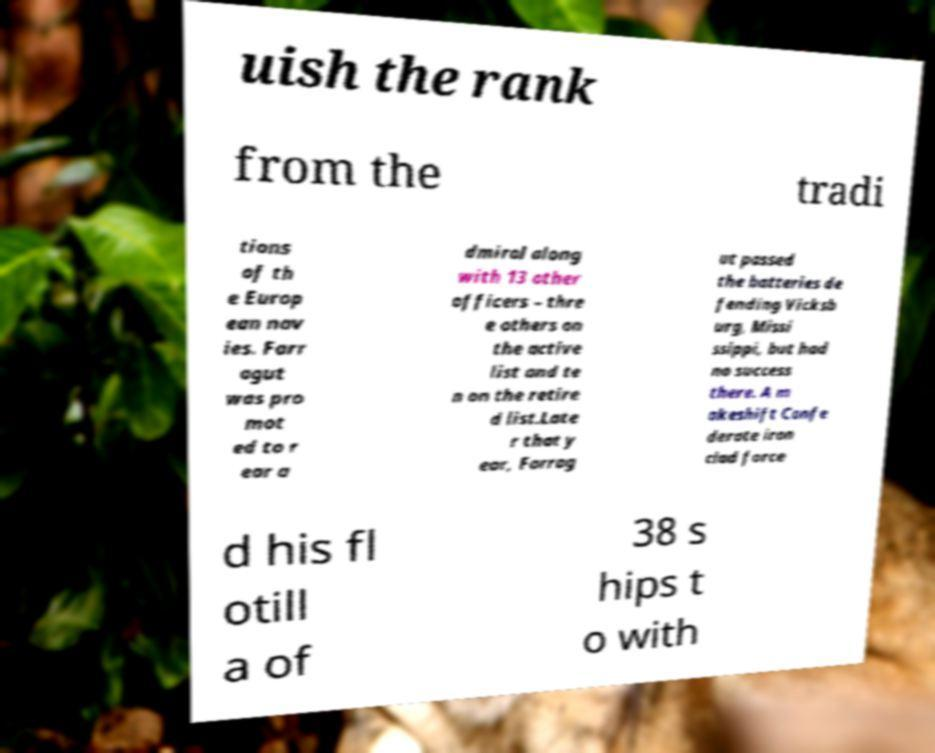What messages or text are displayed in this image? I need them in a readable, typed format. uish the rank from the tradi tions of th e Europ ean nav ies. Farr agut was pro mot ed to r ear a dmiral along with 13 other officers – thre e others on the active list and te n on the retire d list.Late r that y ear, Farrag ut passed the batteries de fending Vicksb urg, Missi ssippi, but had no success there. A m akeshift Confe derate iron clad force d his fl otill a of 38 s hips t o with 